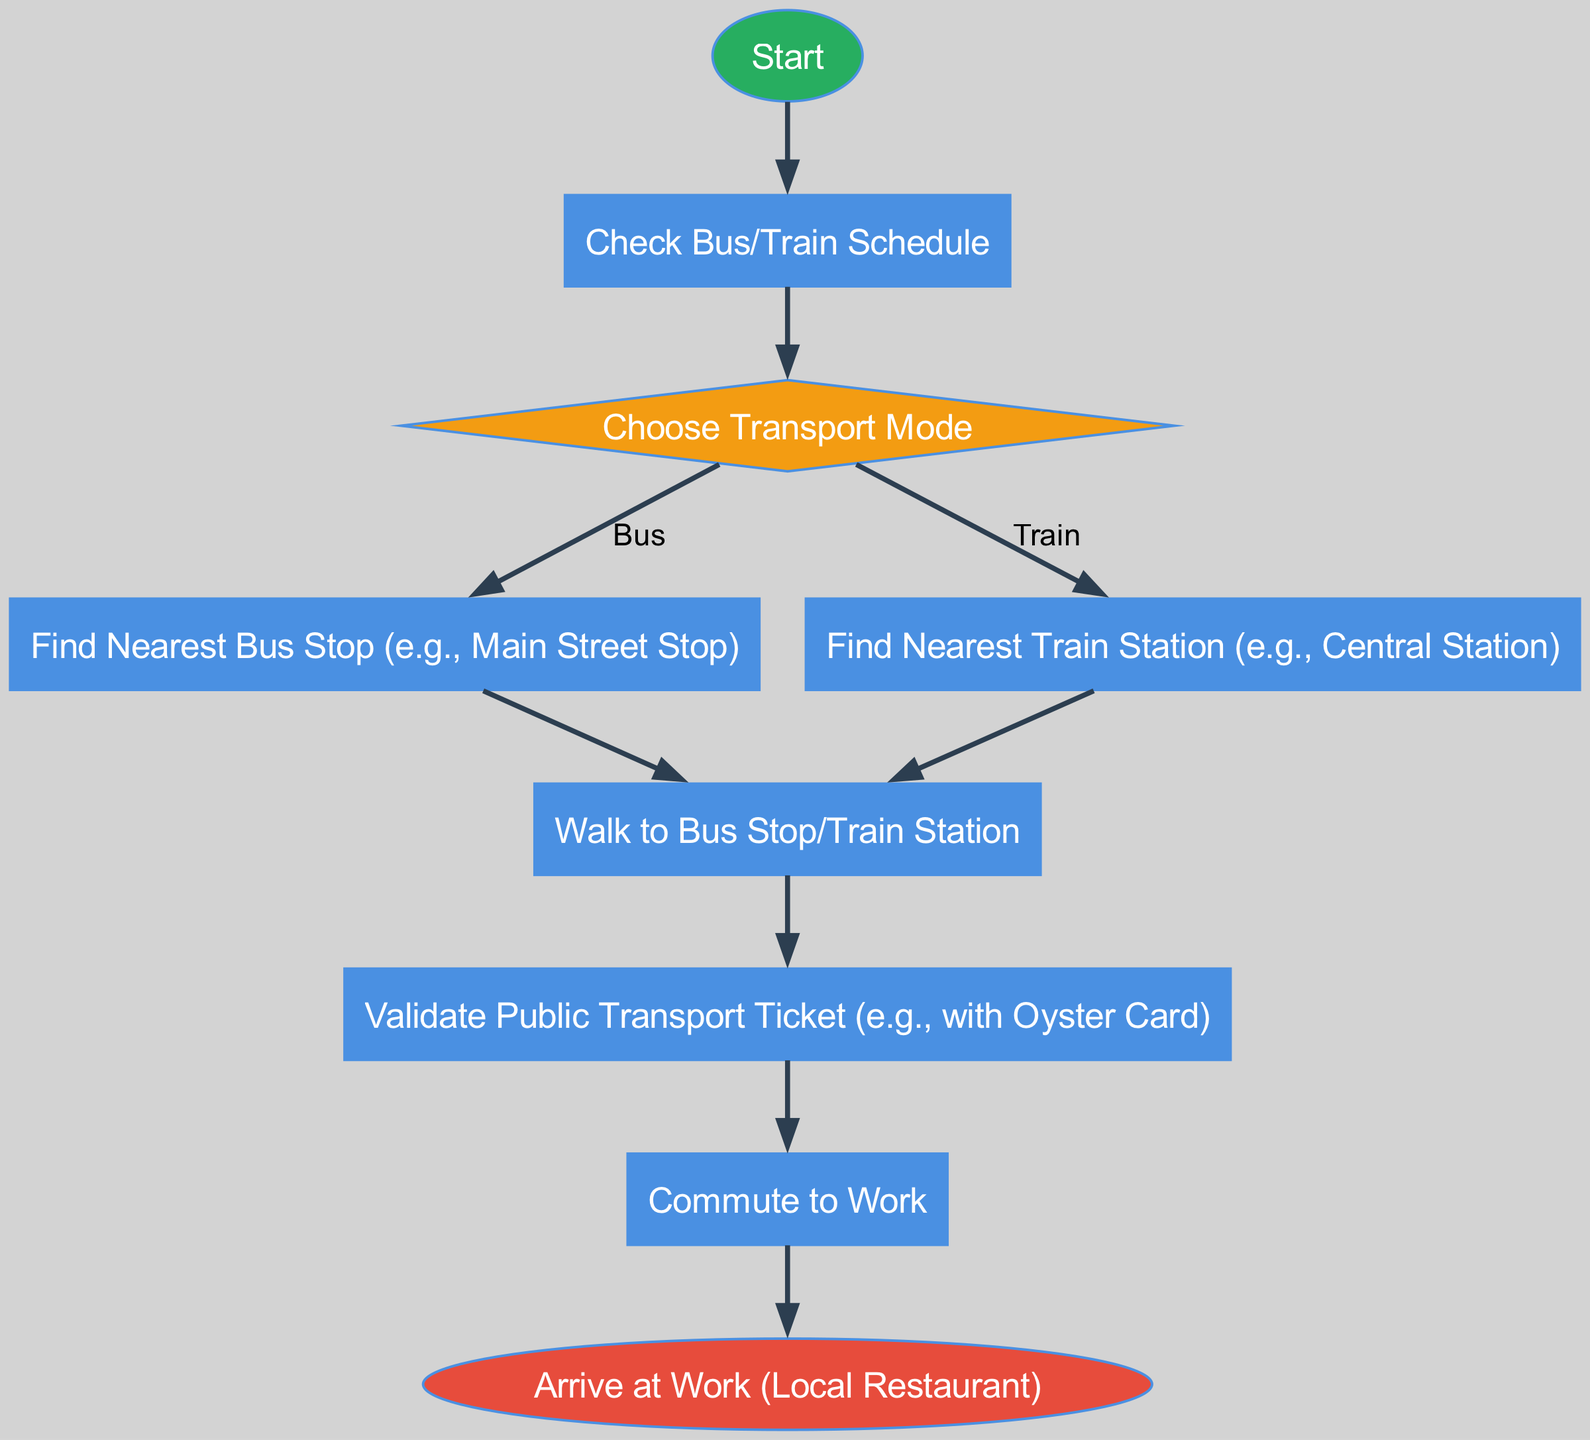What is the first step in the flowchart? The first step in the flowchart is denoted by the "Start" node, which indicates where the process begins.
Answer: Start How many decision nodes are present in the flowchart? The diagram includes one decision node titled "Choose Transport Mode," where a choice between different transport modes is made.
Answer: 1 What are the two transport modes available in the decision node? The choices available at the decision node "Choose Transport Mode" are clearly listed as "Bus" and "Train."
Answer: Bus, Train What is the process following the "Find Nearest Train Station"? After finding the nearest train station, the next step is to "Walk to Bus Stop/Train Station," indicating that the user proceeds to the station directly after locating it.
Answer: Walk to Bus Stop/Train Station What type of node is "Validate Public Transport Ticket"? The node "Validate Public Transport Ticket" is categorized as a process node, indicating an action that must be completed during the commute.
Answer: Process Explain the outcome of validating the ticket. After the step of validating the ticket is completed, the flow proceeds to the next node, which is "Commute to Work," indicating that the validation allows the user to enter the transport system and travel to work.
Answer: Commute to Work What is the final step in the commute process? The final step is represented by the "Arrive at Work (Local Restaurant)" node, which indicates the endpoint of the commuting process after all preceding actions have been completed.
Answer: Arrive at Work (Local Restaurant) What follows the "Check Bus/Train Schedule" in the flowchart? Immediately after "Check Bus/Train Schedule," the flow moves to the decision node "Choose Transport Mode," specifying that based on the schedule, the user will decide how to proceed with their commute.
Answer: Choose Transport Mode How is the "Choose Transport Mode" node connected to the bus and train nodes? The "Choose Transport Mode" node has two edges leading out: one to "Find Nearest Bus Stop" and another to "Find Nearest Train Station," establishing a clear path to either option based on user choice.
Answer: Find Nearest Bus Stop, Find Nearest Train Station 